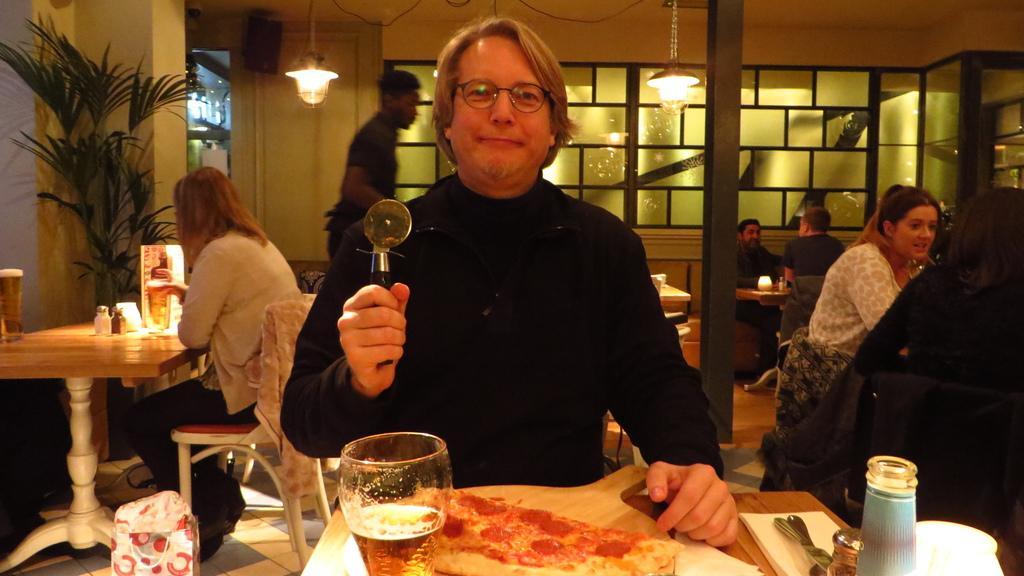In one or two sentences, can you explain what this image depicts? In this image there are tables and chairs. There are people having their food. On the table there are glasses and spoons. On the left side there is a tree. In the background there are lights. There is a wall with glasses on the backside. 